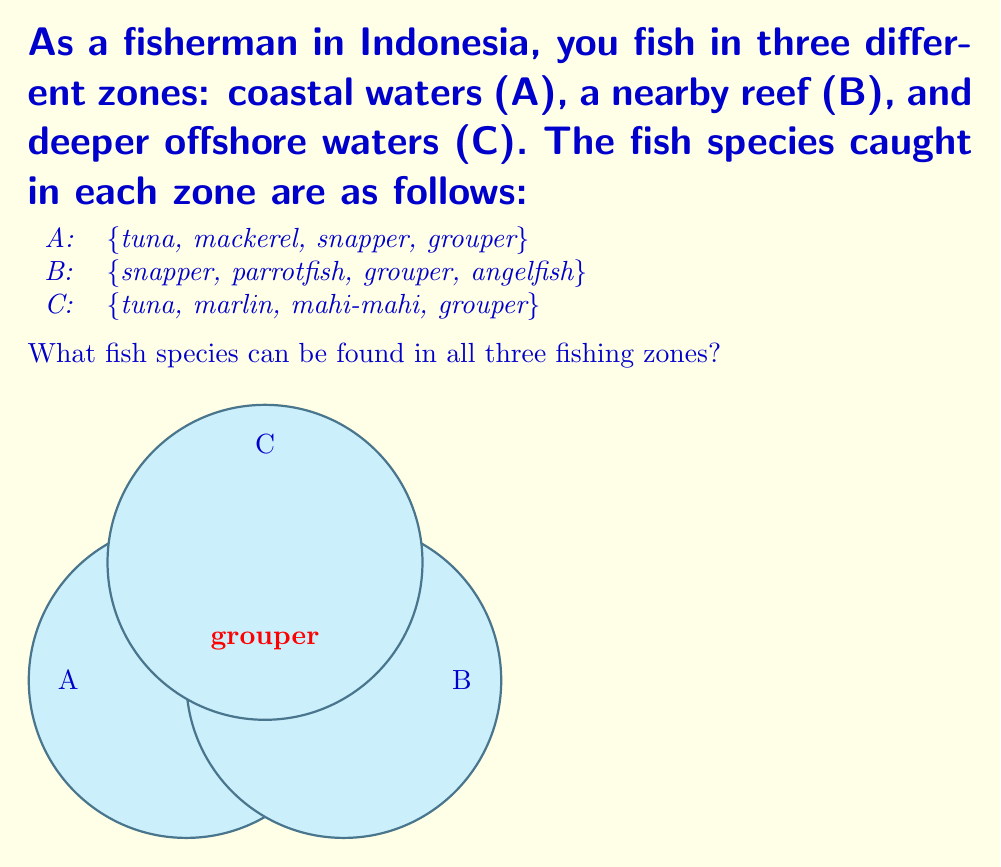Teach me how to tackle this problem. To solve this problem, we need to find the intersection of all three sets. Let's approach this step-by-step:

1) First, let's define our sets formally:
   A = {tuna, mackerel, snapper, grouper}
   B = {snapper, parrotfish, grouper, angelfish}
   C = {tuna, marlin, mahi-mahi, grouper}

2) The intersection of all three sets is denoted as $A \cap B \cap C$. This represents the elements that are common to all three sets.

3) Let's start by finding the intersection of A and B:
   A ∩ B = {snapper, grouper}

4) Now, let's intersect this result with C:
   (A ∩ B) ∩ C = {snapper, grouper} ∩ {tuna, marlin, mahi-mahi, grouper}

5) The only element common to both these sets is "grouper".

Therefore, the fish species that can be found in all three fishing zones is only grouper.

This can be written formally as:

$$A \cap B \cap C = \{grouper\}$$
Answer: {grouper} 